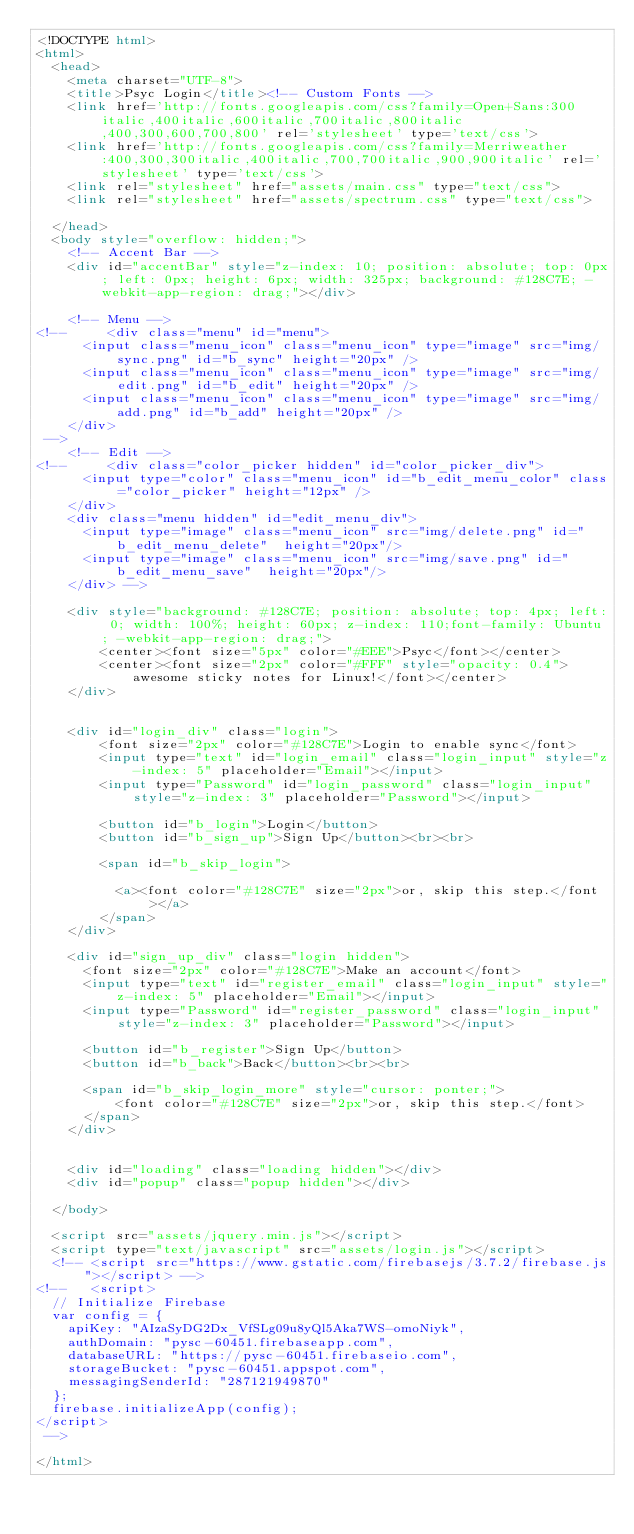<code> <loc_0><loc_0><loc_500><loc_500><_HTML_><!DOCTYPE html>
<html>
  <head>
    <meta charset="UTF-8">
    <title>Psyc Login</title><!-- Custom Fonts -->
    <link href='http://fonts.googleapis.com/css?family=Open+Sans:300italic,400italic,600italic,700italic,800italic,400,300,600,700,800' rel='stylesheet' type='text/css'>
    <link href='http://fonts.googleapis.com/css?family=Merriweather:400,300,300italic,400italic,700,700italic,900,900italic' rel='stylesheet' type='text/css'>
    <link rel="stylesheet" href="assets/main.css" type="text/css">
    <link rel="stylesheet" href="assets/spectrum.css" type="text/css">

  </head>
  <body style="overflow: hidden;">
    <!-- Accent Bar -->
    <div id="accentBar" style="z-index: 10; position: absolute; top: 0px; left: 0px; height: 6px; width: 325px; background: #128C7E; -webkit-app-region: drag;"></div>

    <!-- Menu -->
<!--     <div class="menu" id="menu">
      <input class="menu_icon" class="menu_icon" type="image" src="img/sync.png" id="b_sync" height="20px" />
      <input class="menu_icon" class="menu_icon" type="image" src="img/edit.png" id="b_edit" height="20px" />
      <input class="menu_icon" class="menu_icon" type="image" src="img/add.png" id="b_add" height="20px" />
    </div>
 -->
    <!-- Edit -->
<!--     <div class="color_picker hidden" id="color_picker_div">
      <input type="color" class="menu_icon" id="b_edit_menu_color" class="color_picker" height="12px" /> 
    </div>
    <div class="menu hidden" id="edit_menu_div">
      <input type="image" class="menu_icon" src="img/delete.png" id="b_edit_menu_delete"  height="20px"/> 
      <input type="image" class="menu_icon" src="img/save.png" id="b_edit_menu_save"  height="20px"/> 
    </div> -->

    <div style="background: #128C7E; position: absolute; top: 4px; left: 0; width: 100%; height: 60px; z-index: 110;font-family: Ubuntu; -webkit-app-region: drag;">
        <center><font size="5px" color="#EEE">Psyc</font></center>
        <center><font size="2px" color="#FFF" style="opacity: 0.4">awesome sticky notes for Linux!</font></center>
    </div>


    <div id="login_div" class="login">
        <font size="2px" color="#128C7E">Login to enable sync</font>
        <input type="text" id="login_email" class="login_input" style="z-index: 5" placeholder="Email"></input>
        <input type="Password" id="login_password" class="login_input" style="z-index: 3" placeholder="Password"></input>
        
        <button id="b_login">Login</button>
        <button id="b_sign_up">Sign Up</button><br><br>

        <span id="b_skip_login">
            
          <a><font color="#128C7E" size="2px">or, skip this step.</font></a>
        </span>
    </div>

    <div id="sign_up_div" class="login hidden">
      <font size="2px" color="#128C7E">Make an account</font>
      <input type="text" id="register_email" class="login_input" style="z-index: 5" placeholder="Email"></input>
      <input type="Password" id="register_password" class="login_input" style="z-index: 3" placeholder="Password"></input>
      
      <button id="b_register">Sign Up</button>
      <button id="b_back">Back</button><br><br>

      <span id="b_skip_login_more" style="cursor: ponter;">
          <font color="#128C7E" size="2px">or, skip this step.</font>
      </span>
    </div>


    <div id="loading" class="loading hidden"></div>
    <div id="popup" class="popup hidden"></div>

  </body>

  <script src="assets/jquery.min.js"></script>
  <script type="text/javascript" src="assets/login.js"></script>
  <!-- <script src="https://www.gstatic.com/firebasejs/3.7.2/firebase.js"></script> -->
<!--   <script>
  // Initialize Firebase
  var config = {
    apiKey: "AIzaSyDG2Dx_VfSLg09u8yQl5Aka7WS-omoNiyk",
    authDomain: "pysc-60451.firebaseapp.com",
    databaseURL: "https://pysc-60451.firebaseio.com",
    storageBucket: "pysc-60451.appspot.com",
    messagingSenderId: "287121949870"
  };
  firebase.initializeApp(config);
</script>
 -->

</html>
</code> 